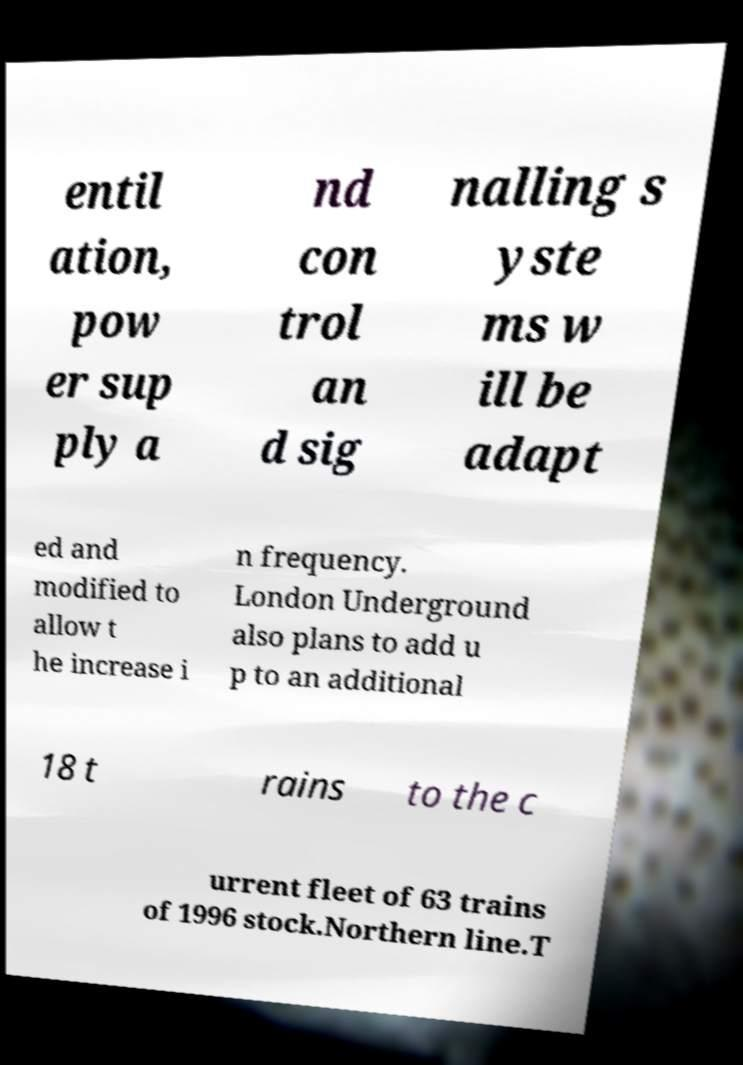Could you extract and type out the text from this image? entil ation, pow er sup ply a nd con trol an d sig nalling s yste ms w ill be adapt ed and modified to allow t he increase i n frequency. London Underground also plans to add u p to an additional 18 t rains to the c urrent fleet of 63 trains of 1996 stock.Northern line.T 